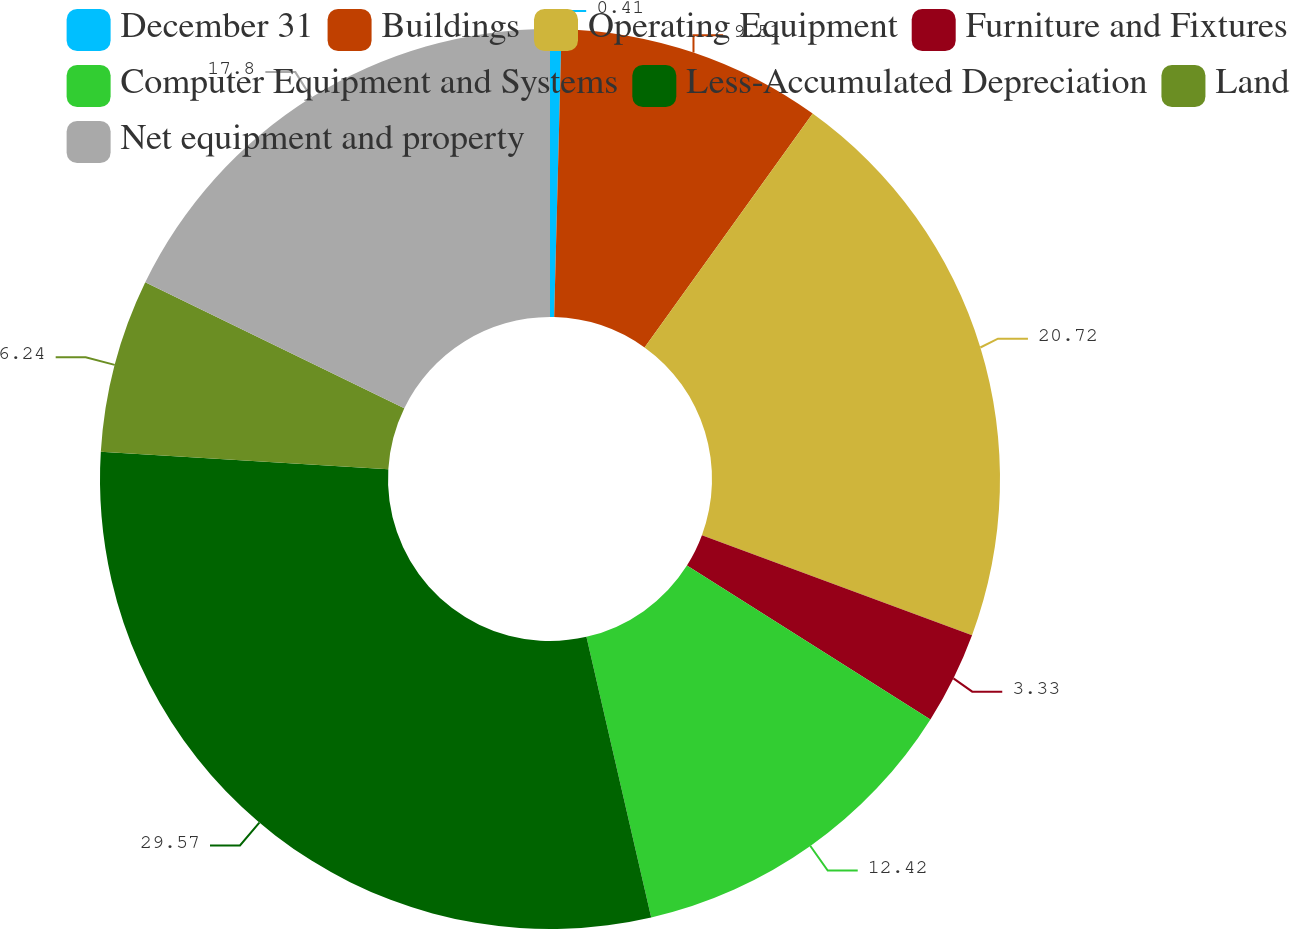Convert chart. <chart><loc_0><loc_0><loc_500><loc_500><pie_chart><fcel>December 31<fcel>Buildings<fcel>Operating Equipment<fcel>Furniture and Fixtures<fcel>Computer Equipment and Systems<fcel>Less-Accumulated Depreciation<fcel>Land<fcel>Net equipment and property<nl><fcel>0.41%<fcel>9.51%<fcel>20.72%<fcel>3.33%<fcel>12.42%<fcel>29.57%<fcel>6.24%<fcel>17.8%<nl></chart> 